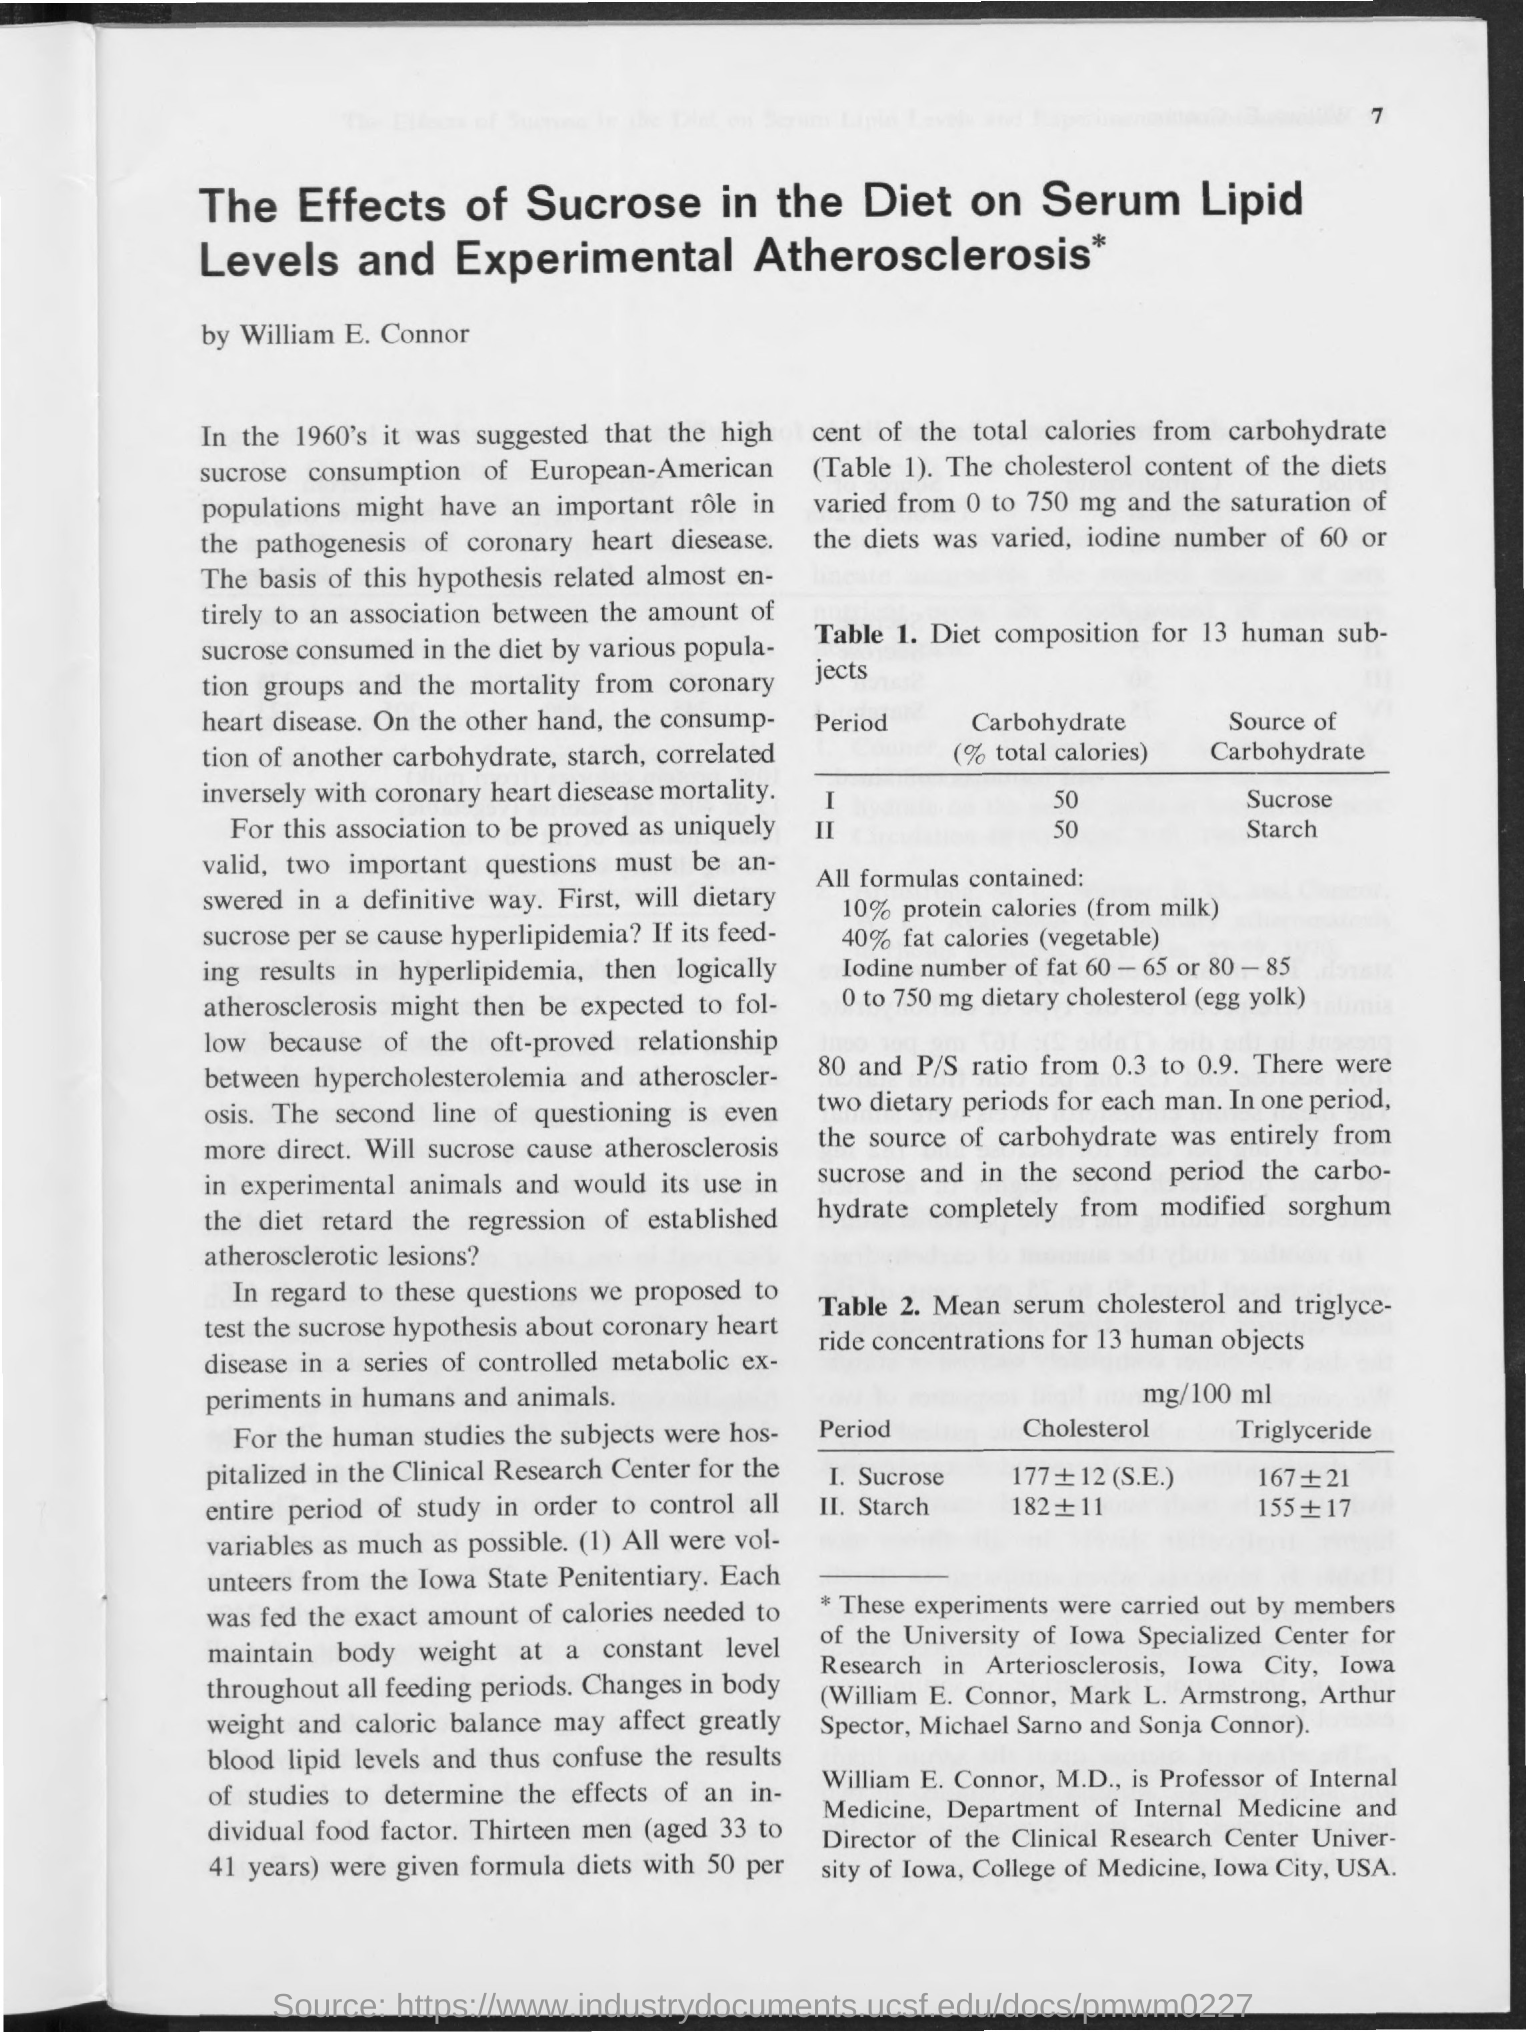List a handful of essential elements in this visual. The carbohydrate content, expressed as a percentage of total calories, was 50% in period 1. Period 2 obtains carbohydrates from starch. The source of carbohydrates in Period 1 is sucrose. The value of carbohydrate as a percentage of total calories in period 2 is 50%. 